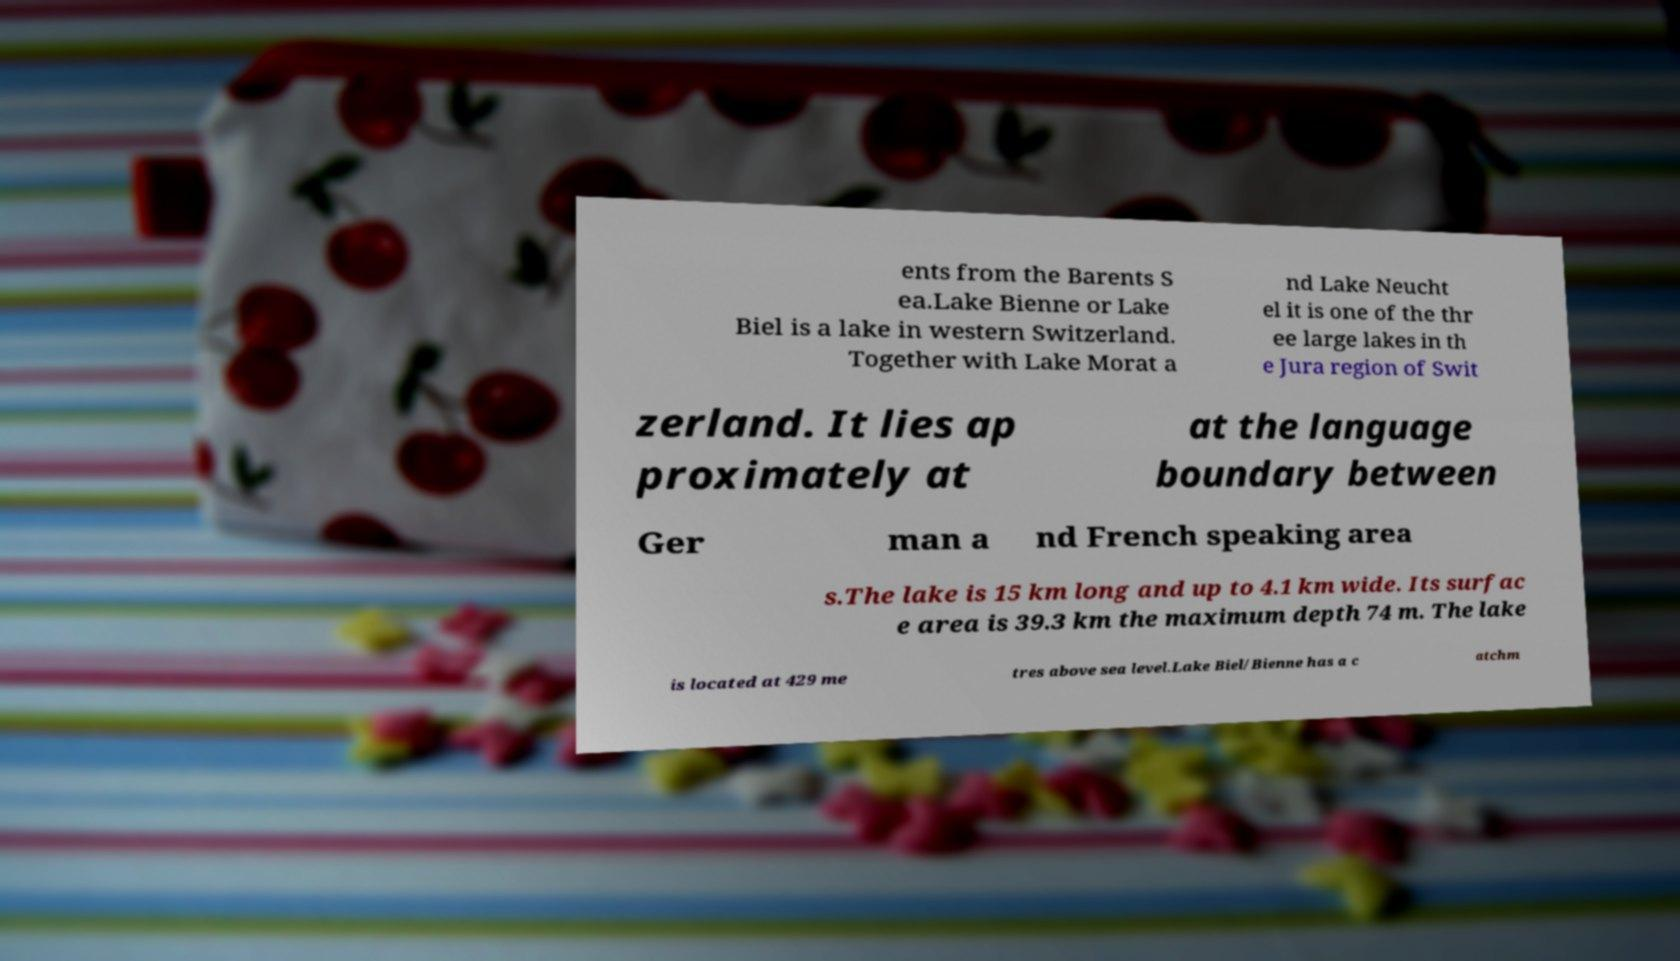There's text embedded in this image that I need extracted. Can you transcribe it verbatim? ents from the Barents S ea.Lake Bienne or Lake Biel is a lake in western Switzerland. Together with Lake Morat a nd Lake Neucht el it is one of the thr ee large lakes in th e Jura region of Swit zerland. It lies ap proximately at at the language boundary between Ger man a nd French speaking area s.The lake is 15 km long and up to 4.1 km wide. Its surfac e area is 39.3 km the maximum depth 74 m. The lake is located at 429 me tres above sea level.Lake Biel/Bienne has a c atchm 